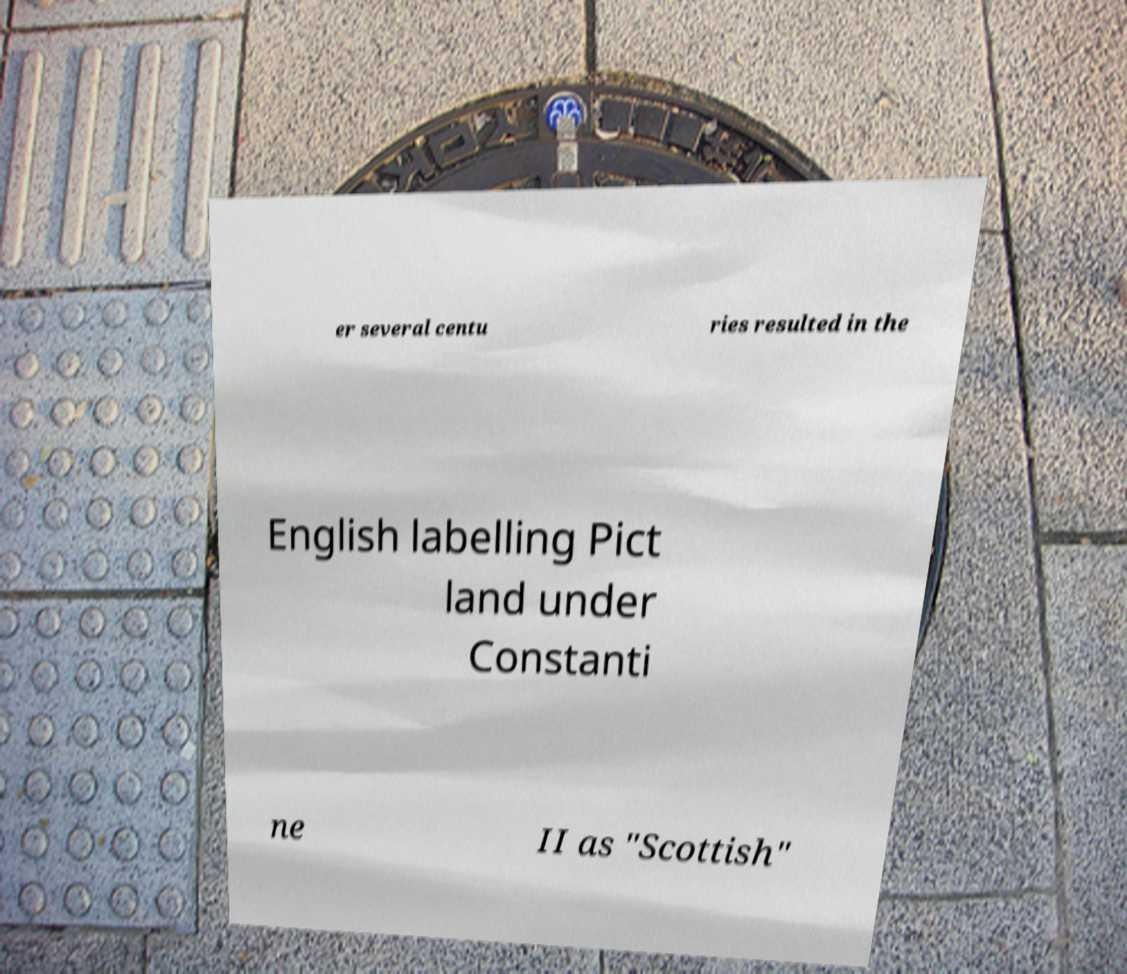Could you extract and type out the text from this image? er several centu ries resulted in the English labelling Pict land under Constanti ne II as "Scottish" 